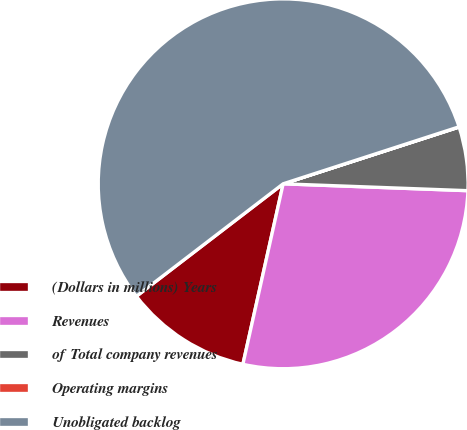<chart> <loc_0><loc_0><loc_500><loc_500><pie_chart><fcel>(Dollars in millions) Years<fcel>Revenues<fcel>of Total company revenues<fcel>Operating margins<fcel>Unobligated backlog<nl><fcel>11.1%<fcel>27.9%<fcel>5.56%<fcel>0.02%<fcel>55.42%<nl></chart> 